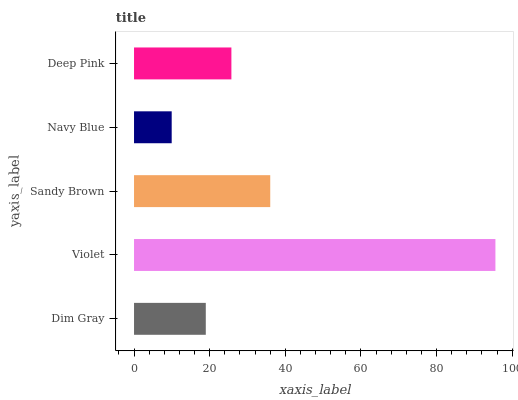Is Navy Blue the minimum?
Answer yes or no. Yes. Is Violet the maximum?
Answer yes or no. Yes. Is Sandy Brown the minimum?
Answer yes or no. No. Is Sandy Brown the maximum?
Answer yes or no. No. Is Violet greater than Sandy Brown?
Answer yes or no. Yes. Is Sandy Brown less than Violet?
Answer yes or no. Yes. Is Sandy Brown greater than Violet?
Answer yes or no. No. Is Violet less than Sandy Brown?
Answer yes or no. No. Is Deep Pink the high median?
Answer yes or no. Yes. Is Deep Pink the low median?
Answer yes or no. Yes. Is Dim Gray the high median?
Answer yes or no. No. Is Navy Blue the low median?
Answer yes or no. No. 